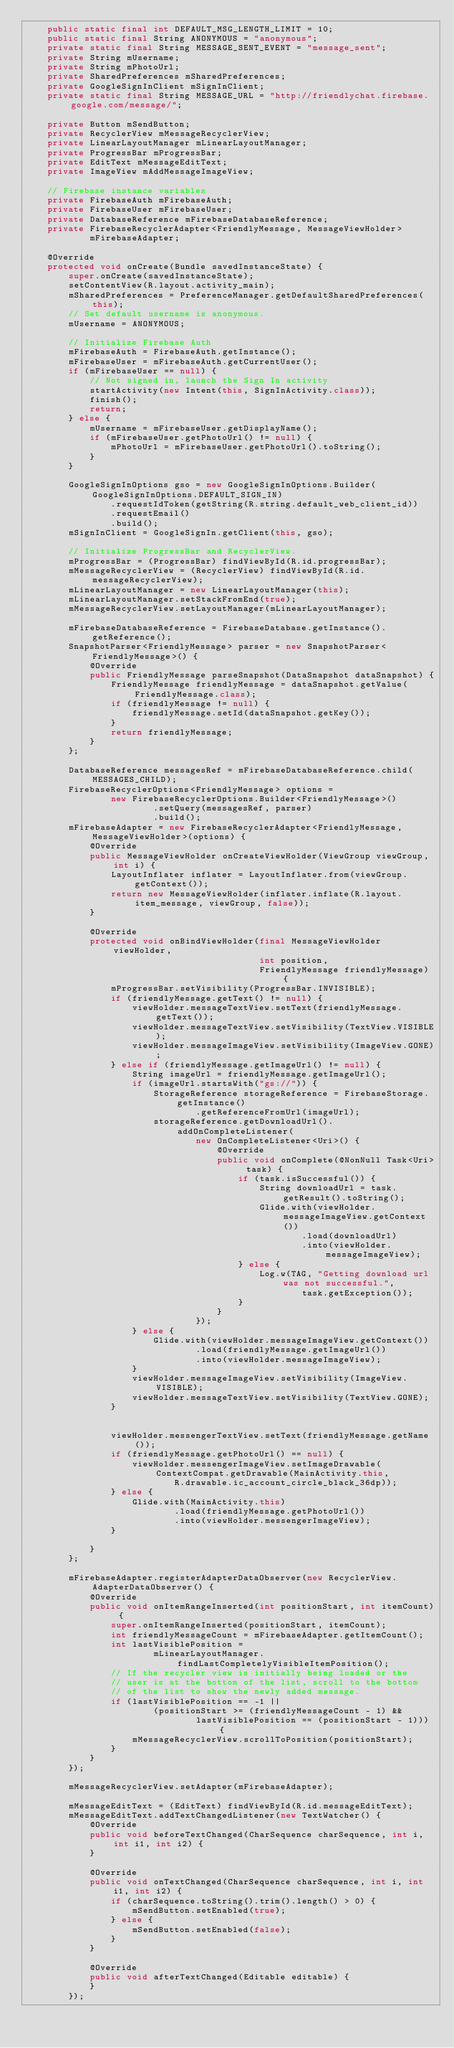<code> <loc_0><loc_0><loc_500><loc_500><_Java_>    public static final int DEFAULT_MSG_LENGTH_LIMIT = 10;
    public static final String ANONYMOUS = "anonymous";
    private static final String MESSAGE_SENT_EVENT = "message_sent";
    private String mUsername;
    private String mPhotoUrl;
    private SharedPreferences mSharedPreferences;
    private GoogleSignInClient mSignInClient;
    private static final String MESSAGE_URL = "http://friendlychat.firebase.google.com/message/";

    private Button mSendButton;
    private RecyclerView mMessageRecyclerView;
    private LinearLayoutManager mLinearLayoutManager;
    private ProgressBar mProgressBar;
    private EditText mMessageEditText;
    private ImageView mAddMessageImageView;

    // Firebase instance variables
    private FirebaseAuth mFirebaseAuth;
    private FirebaseUser mFirebaseUser;
    private DatabaseReference mFirebaseDatabaseReference;
    private FirebaseRecyclerAdapter<FriendlyMessage, MessageViewHolder>
            mFirebaseAdapter;

    @Override
    protected void onCreate(Bundle savedInstanceState) {
        super.onCreate(savedInstanceState);
        setContentView(R.layout.activity_main);
        mSharedPreferences = PreferenceManager.getDefaultSharedPreferences(this);
        // Set default username is anonymous.
        mUsername = ANONYMOUS;

        // Initialize Firebase Auth
        mFirebaseAuth = FirebaseAuth.getInstance();
        mFirebaseUser = mFirebaseAuth.getCurrentUser();
        if (mFirebaseUser == null) {
            // Not signed in, launch the Sign In activity
            startActivity(new Intent(this, SignInActivity.class));
            finish();
            return;
        } else {
            mUsername = mFirebaseUser.getDisplayName();
            if (mFirebaseUser.getPhotoUrl() != null) {
                mPhotoUrl = mFirebaseUser.getPhotoUrl().toString();
            }
        }

        GoogleSignInOptions gso = new GoogleSignInOptions.Builder(GoogleSignInOptions.DEFAULT_SIGN_IN)
                .requestIdToken(getString(R.string.default_web_client_id))
                .requestEmail()
                .build();
        mSignInClient = GoogleSignIn.getClient(this, gso);

        // Initialize ProgressBar and RecyclerView.
        mProgressBar = (ProgressBar) findViewById(R.id.progressBar);
        mMessageRecyclerView = (RecyclerView) findViewById(R.id.messageRecyclerView);
        mLinearLayoutManager = new LinearLayoutManager(this);
        mLinearLayoutManager.setStackFromEnd(true);
        mMessageRecyclerView.setLayoutManager(mLinearLayoutManager);

        mFirebaseDatabaseReference = FirebaseDatabase.getInstance().getReference();
        SnapshotParser<FriendlyMessage> parser = new SnapshotParser<FriendlyMessage>() {
            @Override
            public FriendlyMessage parseSnapshot(DataSnapshot dataSnapshot) {
                FriendlyMessage friendlyMessage = dataSnapshot.getValue(FriendlyMessage.class);
                if (friendlyMessage != null) {
                    friendlyMessage.setId(dataSnapshot.getKey());
                }
                return friendlyMessage;
            }
        };

        DatabaseReference messagesRef = mFirebaseDatabaseReference.child(MESSAGES_CHILD);
        FirebaseRecyclerOptions<FriendlyMessage> options =
                new FirebaseRecyclerOptions.Builder<FriendlyMessage>()
                        .setQuery(messagesRef, parser)
                        .build();
        mFirebaseAdapter = new FirebaseRecyclerAdapter<FriendlyMessage, MessageViewHolder>(options) {
            @Override
            public MessageViewHolder onCreateViewHolder(ViewGroup viewGroup, int i) {
                LayoutInflater inflater = LayoutInflater.from(viewGroup.getContext());
                return new MessageViewHolder(inflater.inflate(R.layout.item_message, viewGroup, false));
            }

            @Override
            protected void onBindViewHolder(final MessageViewHolder viewHolder,
                                            int position,
                                            FriendlyMessage friendlyMessage) {
                mProgressBar.setVisibility(ProgressBar.INVISIBLE);
                if (friendlyMessage.getText() != null) {
                    viewHolder.messageTextView.setText(friendlyMessage.getText());
                    viewHolder.messageTextView.setVisibility(TextView.VISIBLE);
                    viewHolder.messageImageView.setVisibility(ImageView.GONE);
                } else if (friendlyMessage.getImageUrl() != null) {
                    String imageUrl = friendlyMessage.getImageUrl();
                    if (imageUrl.startsWith("gs://")) {
                        StorageReference storageReference = FirebaseStorage.getInstance()
                                .getReferenceFromUrl(imageUrl);
                        storageReference.getDownloadUrl().addOnCompleteListener(
                                new OnCompleteListener<Uri>() {
                                    @Override
                                    public void onComplete(@NonNull Task<Uri> task) {
                                        if (task.isSuccessful()) {
                                            String downloadUrl = task.getResult().toString();
                                            Glide.with(viewHolder.messageImageView.getContext())
                                                    .load(downloadUrl)
                                                    .into(viewHolder.messageImageView);
                                        } else {
                                            Log.w(TAG, "Getting download url was not successful.",
                                                    task.getException());
                                        }
                                    }
                                });
                    } else {
                        Glide.with(viewHolder.messageImageView.getContext())
                                .load(friendlyMessage.getImageUrl())
                                .into(viewHolder.messageImageView);
                    }
                    viewHolder.messageImageView.setVisibility(ImageView.VISIBLE);
                    viewHolder.messageTextView.setVisibility(TextView.GONE);
                }


                viewHolder.messengerTextView.setText(friendlyMessage.getName());
                if (friendlyMessage.getPhotoUrl() == null) {
                    viewHolder.messengerImageView.setImageDrawable(ContextCompat.getDrawable(MainActivity.this,
                            R.drawable.ic_account_circle_black_36dp));
                } else {
                    Glide.with(MainActivity.this)
                            .load(friendlyMessage.getPhotoUrl())
                            .into(viewHolder.messengerImageView);
                }

            }
        };

        mFirebaseAdapter.registerAdapterDataObserver(new RecyclerView.AdapterDataObserver() {
            @Override
            public void onItemRangeInserted(int positionStart, int itemCount) {
                super.onItemRangeInserted(positionStart, itemCount);
                int friendlyMessageCount = mFirebaseAdapter.getItemCount();
                int lastVisiblePosition =
                        mLinearLayoutManager.findLastCompletelyVisibleItemPosition();
                // If the recycler view is initially being loaded or the
                // user is at the bottom of the list, scroll to the bottom
                // of the list to show the newly added message.
                if (lastVisiblePosition == -1 ||
                        (positionStart >= (friendlyMessageCount - 1) &&
                                lastVisiblePosition == (positionStart - 1))) {
                    mMessageRecyclerView.scrollToPosition(positionStart);
                }
            }
        });

        mMessageRecyclerView.setAdapter(mFirebaseAdapter);

        mMessageEditText = (EditText) findViewById(R.id.messageEditText);
        mMessageEditText.addTextChangedListener(new TextWatcher() {
            @Override
            public void beforeTextChanged(CharSequence charSequence, int i, int i1, int i2) {
            }

            @Override
            public void onTextChanged(CharSequence charSequence, int i, int i1, int i2) {
                if (charSequence.toString().trim().length() > 0) {
                    mSendButton.setEnabled(true);
                } else {
                    mSendButton.setEnabled(false);
                }
            }

            @Override
            public void afterTextChanged(Editable editable) {
            }
        });
</code> 